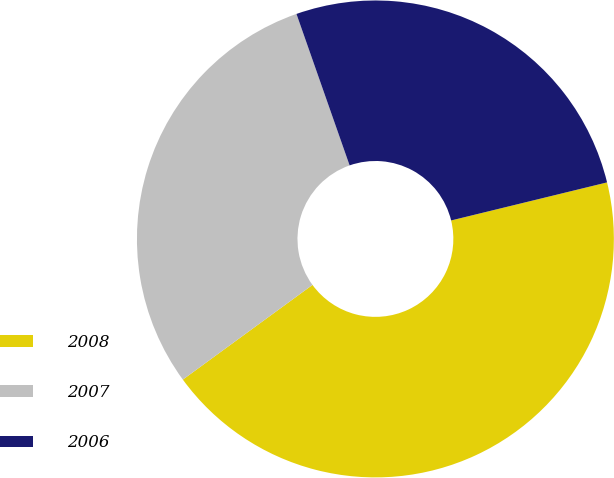Convert chart. <chart><loc_0><loc_0><loc_500><loc_500><pie_chart><fcel>2008<fcel>2007<fcel>2006<nl><fcel>43.77%<fcel>29.67%<fcel>26.56%<nl></chart> 